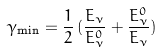<formula> <loc_0><loc_0><loc_500><loc_500>\gamma _ { \min } = \frac { 1 } { 2 } \, ( \frac { E _ { \nu } } { E _ { \nu } ^ { 0 } } + \frac { E _ { \nu } ^ { 0 } } { E _ { \nu } } )</formula> 